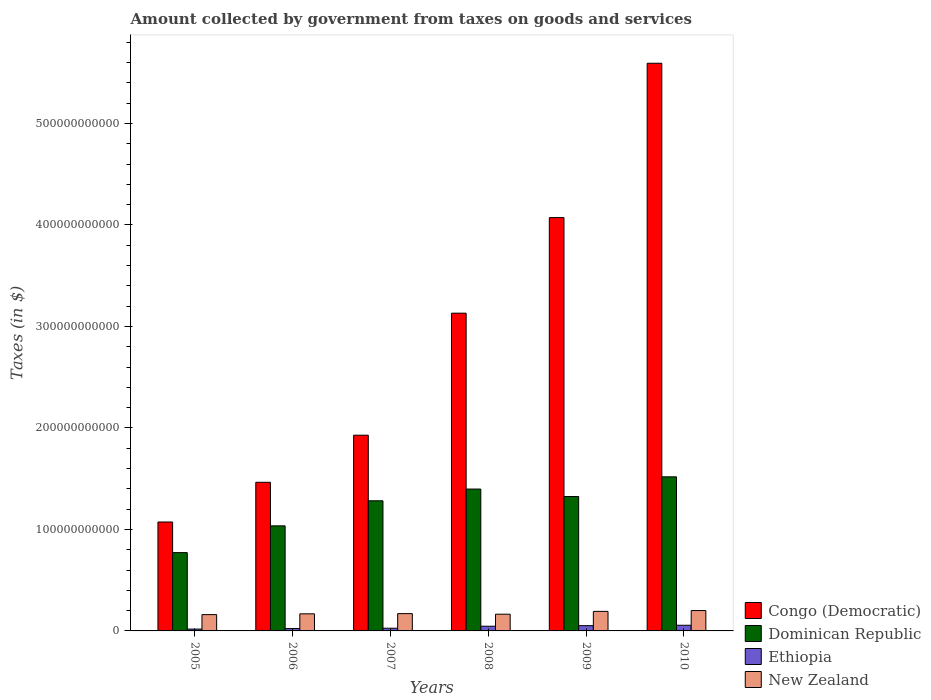How many different coloured bars are there?
Your response must be concise. 4. Are the number of bars on each tick of the X-axis equal?
Provide a succinct answer. Yes. In how many cases, is the number of bars for a given year not equal to the number of legend labels?
Provide a succinct answer. 0. What is the amount collected by government from taxes on goods and services in Dominican Republic in 2006?
Keep it short and to the point. 1.04e+11. Across all years, what is the maximum amount collected by government from taxes on goods and services in Dominican Republic?
Provide a short and direct response. 1.52e+11. Across all years, what is the minimum amount collected by government from taxes on goods and services in Dominican Republic?
Offer a terse response. 7.71e+1. In which year was the amount collected by government from taxes on goods and services in Congo (Democratic) maximum?
Provide a succinct answer. 2010. What is the total amount collected by government from taxes on goods and services in Congo (Democratic) in the graph?
Provide a short and direct response. 1.73e+12. What is the difference between the amount collected by government from taxes on goods and services in Ethiopia in 2006 and that in 2008?
Provide a short and direct response. -2.31e+09. What is the difference between the amount collected by government from taxes on goods and services in New Zealand in 2010 and the amount collected by government from taxes on goods and services in Ethiopia in 2006?
Make the answer very short. 1.77e+1. What is the average amount collected by government from taxes on goods and services in Congo (Democratic) per year?
Give a very brief answer. 2.88e+11. In the year 2006, what is the difference between the amount collected by government from taxes on goods and services in Ethiopia and amount collected by government from taxes on goods and services in New Zealand?
Your answer should be very brief. -1.45e+1. What is the ratio of the amount collected by government from taxes on goods and services in Congo (Democratic) in 2007 to that in 2008?
Offer a terse response. 0.62. What is the difference between the highest and the second highest amount collected by government from taxes on goods and services in New Zealand?
Offer a terse response. 8.25e+08. What is the difference between the highest and the lowest amount collected by government from taxes on goods and services in New Zealand?
Provide a succinct answer. 4.00e+09. In how many years, is the amount collected by government from taxes on goods and services in Dominican Republic greater than the average amount collected by government from taxes on goods and services in Dominican Republic taken over all years?
Ensure brevity in your answer.  4. Is the sum of the amount collected by government from taxes on goods and services in Dominican Republic in 2005 and 2008 greater than the maximum amount collected by government from taxes on goods and services in New Zealand across all years?
Your answer should be compact. Yes. What does the 4th bar from the left in 2009 represents?
Keep it short and to the point. New Zealand. What does the 4th bar from the right in 2006 represents?
Your answer should be very brief. Congo (Democratic). How many bars are there?
Keep it short and to the point. 24. Are all the bars in the graph horizontal?
Make the answer very short. No. What is the difference between two consecutive major ticks on the Y-axis?
Your answer should be very brief. 1.00e+11. How are the legend labels stacked?
Your answer should be very brief. Vertical. What is the title of the graph?
Your response must be concise. Amount collected by government from taxes on goods and services. What is the label or title of the X-axis?
Make the answer very short. Years. What is the label or title of the Y-axis?
Ensure brevity in your answer.  Taxes (in $). What is the Taxes (in $) in Congo (Democratic) in 2005?
Provide a short and direct response. 1.07e+11. What is the Taxes (in $) of Dominican Republic in 2005?
Your answer should be compact. 7.71e+1. What is the Taxes (in $) in Ethiopia in 2005?
Make the answer very short. 1.82e+09. What is the Taxes (in $) of New Zealand in 2005?
Offer a very short reply. 1.61e+1. What is the Taxes (in $) in Congo (Democratic) in 2006?
Provide a short and direct response. 1.46e+11. What is the Taxes (in $) of Dominican Republic in 2006?
Give a very brief answer. 1.04e+11. What is the Taxes (in $) in Ethiopia in 2006?
Your answer should be compact. 2.33e+09. What is the Taxes (in $) of New Zealand in 2006?
Your answer should be compact. 1.68e+1. What is the Taxes (in $) in Congo (Democratic) in 2007?
Offer a terse response. 1.93e+11. What is the Taxes (in $) of Dominican Republic in 2007?
Give a very brief answer. 1.28e+11. What is the Taxes (in $) in Ethiopia in 2007?
Provide a succinct answer. 2.66e+09. What is the Taxes (in $) of New Zealand in 2007?
Give a very brief answer. 1.70e+1. What is the Taxes (in $) in Congo (Democratic) in 2008?
Offer a very short reply. 3.13e+11. What is the Taxes (in $) of Dominican Republic in 2008?
Ensure brevity in your answer.  1.40e+11. What is the Taxes (in $) in Ethiopia in 2008?
Your answer should be compact. 4.63e+09. What is the Taxes (in $) of New Zealand in 2008?
Your response must be concise. 1.65e+1. What is the Taxes (in $) of Congo (Democratic) in 2009?
Provide a short and direct response. 4.07e+11. What is the Taxes (in $) in Dominican Republic in 2009?
Your answer should be very brief. 1.32e+11. What is the Taxes (in $) in Ethiopia in 2009?
Provide a short and direct response. 5.20e+09. What is the Taxes (in $) of New Zealand in 2009?
Offer a terse response. 1.92e+1. What is the Taxes (in $) of Congo (Democratic) in 2010?
Offer a terse response. 5.59e+11. What is the Taxes (in $) in Dominican Republic in 2010?
Offer a very short reply. 1.52e+11. What is the Taxes (in $) of Ethiopia in 2010?
Your response must be concise. 5.58e+09. What is the Taxes (in $) of New Zealand in 2010?
Offer a very short reply. 2.01e+1. Across all years, what is the maximum Taxes (in $) in Congo (Democratic)?
Keep it short and to the point. 5.59e+11. Across all years, what is the maximum Taxes (in $) in Dominican Republic?
Your answer should be very brief. 1.52e+11. Across all years, what is the maximum Taxes (in $) of Ethiopia?
Offer a very short reply. 5.58e+09. Across all years, what is the maximum Taxes (in $) of New Zealand?
Your answer should be compact. 2.01e+1. Across all years, what is the minimum Taxes (in $) of Congo (Democratic)?
Your response must be concise. 1.07e+11. Across all years, what is the minimum Taxes (in $) in Dominican Republic?
Keep it short and to the point. 7.71e+1. Across all years, what is the minimum Taxes (in $) in Ethiopia?
Keep it short and to the point. 1.82e+09. Across all years, what is the minimum Taxes (in $) of New Zealand?
Give a very brief answer. 1.61e+1. What is the total Taxes (in $) of Congo (Democratic) in the graph?
Give a very brief answer. 1.73e+12. What is the total Taxes (in $) of Dominican Republic in the graph?
Give a very brief answer. 7.33e+11. What is the total Taxes (in $) in Ethiopia in the graph?
Your answer should be very brief. 2.22e+1. What is the total Taxes (in $) of New Zealand in the graph?
Give a very brief answer. 1.06e+11. What is the difference between the Taxes (in $) in Congo (Democratic) in 2005 and that in 2006?
Give a very brief answer. -3.91e+1. What is the difference between the Taxes (in $) of Dominican Republic in 2005 and that in 2006?
Offer a very short reply. -2.64e+1. What is the difference between the Taxes (in $) in Ethiopia in 2005 and that in 2006?
Provide a succinct answer. -5.09e+08. What is the difference between the Taxes (in $) of New Zealand in 2005 and that in 2006?
Your answer should be compact. -7.69e+08. What is the difference between the Taxes (in $) in Congo (Democratic) in 2005 and that in 2007?
Provide a succinct answer. -8.55e+1. What is the difference between the Taxes (in $) of Dominican Republic in 2005 and that in 2007?
Make the answer very short. -5.11e+1. What is the difference between the Taxes (in $) in Ethiopia in 2005 and that in 2007?
Provide a short and direct response. -8.40e+08. What is the difference between the Taxes (in $) in New Zealand in 2005 and that in 2007?
Offer a terse response. -9.82e+08. What is the difference between the Taxes (in $) in Congo (Democratic) in 2005 and that in 2008?
Provide a short and direct response. -2.06e+11. What is the difference between the Taxes (in $) of Dominican Republic in 2005 and that in 2008?
Provide a short and direct response. -6.26e+1. What is the difference between the Taxes (in $) of Ethiopia in 2005 and that in 2008?
Keep it short and to the point. -2.81e+09. What is the difference between the Taxes (in $) in New Zealand in 2005 and that in 2008?
Offer a terse response. -4.10e+08. What is the difference between the Taxes (in $) of Congo (Democratic) in 2005 and that in 2009?
Your answer should be compact. -3.00e+11. What is the difference between the Taxes (in $) in Dominican Republic in 2005 and that in 2009?
Keep it short and to the point. -5.53e+1. What is the difference between the Taxes (in $) in Ethiopia in 2005 and that in 2009?
Your response must be concise. -3.38e+09. What is the difference between the Taxes (in $) of New Zealand in 2005 and that in 2009?
Give a very brief answer. -3.18e+09. What is the difference between the Taxes (in $) in Congo (Democratic) in 2005 and that in 2010?
Your answer should be very brief. -4.52e+11. What is the difference between the Taxes (in $) of Dominican Republic in 2005 and that in 2010?
Make the answer very short. -7.47e+1. What is the difference between the Taxes (in $) in Ethiopia in 2005 and that in 2010?
Provide a succinct answer. -3.77e+09. What is the difference between the Taxes (in $) in New Zealand in 2005 and that in 2010?
Provide a short and direct response. -4.00e+09. What is the difference between the Taxes (in $) in Congo (Democratic) in 2006 and that in 2007?
Your answer should be very brief. -4.64e+1. What is the difference between the Taxes (in $) in Dominican Republic in 2006 and that in 2007?
Your answer should be very brief. -2.47e+1. What is the difference between the Taxes (in $) in Ethiopia in 2006 and that in 2007?
Ensure brevity in your answer.  -3.31e+08. What is the difference between the Taxes (in $) in New Zealand in 2006 and that in 2007?
Your response must be concise. -2.13e+08. What is the difference between the Taxes (in $) in Congo (Democratic) in 2006 and that in 2008?
Keep it short and to the point. -1.67e+11. What is the difference between the Taxes (in $) in Dominican Republic in 2006 and that in 2008?
Provide a short and direct response. -3.62e+1. What is the difference between the Taxes (in $) of Ethiopia in 2006 and that in 2008?
Your answer should be compact. -2.31e+09. What is the difference between the Taxes (in $) of New Zealand in 2006 and that in 2008?
Give a very brief answer. 3.59e+08. What is the difference between the Taxes (in $) of Congo (Democratic) in 2006 and that in 2009?
Give a very brief answer. -2.61e+11. What is the difference between the Taxes (in $) of Dominican Republic in 2006 and that in 2009?
Keep it short and to the point. -2.89e+1. What is the difference between the Taxes (in $) of Ethiopia in 2006 and that in 2009?
Your answer should be compact. -2.87e+09. What is the difference between the Taxes (in $) in New Zealand in 2006 and that in 2009?
Provide a short and direct response. -2.41e+09. What is the difference between the Taxes (in $) in Congo (Democratic) in 2006 and that in 2010?
Offer a terse response. -4.13e+11. What is the difference between the Taxes (in $) in Dominican Republic in 2006 and that in 2010?
Your response must be concise. -4.83e+1. What is the difference between the Taxes (in $) of Ethiopia in 2006 and that in 2010?
Offer a terse response. -3.26e+09. What is the difference between the Taxes (in $) of New Zealand in 2006 and that in 2010?
Your answer should be compact. -3.24e+09. What is the difference between the Taxes (in $) of Congo (Democratic) in 2007 and that in 2008?
Keep it short and to the point. -1.20e+11. What is the difference between the Taxes (in $) of Dominican Republic in 2007 and that in 2008?
Offer a very short reply. -1.16e+1. What is the difference between the Taxes (in $) of Ethiopia in 2007 and that in 2008?
Provide a succinct answer. -1.97e+09. What is the difference between the Taxes (in $) of New Zealand in 2007 and that in 2008?
Your answer should be very brief. 5.72e+08. What is the difference between the Taxes (in $) of Congo (Democratic) in 2007 and that in 2009?
Make the answer very short. -2.14e+11. What is the difference between the Taxes (in $) in Dominican Republic in 2007 and that in 2009?
Make the answer very short. -4.20e+09. What is the difference between the Taxes (in $) in Ethiopia in 2007 and that in 2009?
Provide a succinct answer. -2.54e+09. What is the difference between the Taxes (in $) in New Zealand in 2007 and that in 2009?
Your answer should be very brief. -2.20e+09. What is the difference between the Taxes (in $) of Congo (Democratic) in 2007 and that in 2010?
Ensure brevity in your answer.  -3.66e+11. What is the difference between the Taxes (in $) of Dominican Republic in 2007 and that in 2010?
Offer a terse response. -2.36e+1. What is the difference between the Taxes (in $) of Ethiopia in 2007 and that in 2010?
Keep it short and to the point. -2.93e+09. What is the difference between the Taxes (in $) of New Zealand in 2007 and that in 2010?
Make the answer very short. -3.02e+09. What is the difference between the Taxes (in $) in Congo (Democratic) in 2008 and that in 2009?
Give a very brief answer. -9.42e+1. What is the difference between the Taxes (in $) in Dominican Republic in 2008 and that in 2009?
Offer a very short reply. 7.36e+09. What is the difference between the Taxes (in $) in Ethiopia in 2008 and that in 2009?
Keep it short and to the point. -5.68e+08. What is the difference between the Taxes (in $) in New Zealand in 2008 and that in 2009?
Keep it short and to the point. -2.77e+09. What is the difference between the Taxes (in $) in Congo (Democratic) in 2008 and that in 2010?
Your answer should be compact. -2.46e+11. What is the difference between the Taxes (in $) of Dominican Republic in 2008 and that in 2010?
Ensure brevity in your answer.  -1.20e+1. What is the difference between the Taxes (in $) of Ethiopia in 2008 and that in 2010?
Your answer should be compact. -9.51e+08. What is the difference between the Taxes (in $) of New Zealand in 2008 and that in 2010?
Give a very brief answer. -3.60e+09. What is the difference between the Taxes (in $) in Congo (Democratic) in 2009 and that in 2010?
Provide a succinct answer. -1.52e+11. What is the difference between the Taxes (in $) in Dominican Republic in 2009 and that in 2010?
Provide a short and direct response. -1.94e+1. What is the difference between the Taxes (in $) in Ethiopia in 2009 and that in 2010?
Offer a very short reply. -3.83e+08. What is the difference between the Taxes (in $) in New Zealand in 2009 and that in 2010?
Provide a succinct answer. -8.25e+08. What is the difference between the Taxes (in $) in Congo (Democratic) in 2005 and the Taxes (in $) in Dominican Republic in 2006?
Offer a terse response. 3.81e+09. What is the difference between the Taxes (in $) in Congo (Democratic) in 2005 and the Taxes (in $) in Ethiopia in 2006?
Give a very brief answer. 1.05e+11. What is the difference between the Taxes (in $) of Congo (Democratic) in 2005 and the Taxes (in $) of New Zealand in 2006?
Offer a very short reply. 9.05e+1. What is the difference between the Taxes (in $) of Dominican Republic in 2005 and the Taxes (in $) of Ethiopia in 2006?
Your answer should be compact. 7.48e+1. What is the difference between the Taxes (in $) of Dominican Republic in 2005 and the Taxes (in $) of New Zealand in 2006?
Offer a very short reply. 6.03e+1. What is the difference between the Taxes (in $) in Ethiopia in 2005 and the Taxes (in $) in New Zealand in 2006?
Your response must be concise. -1.50e+1. What is the difference between the Taxes (in $) in Congo (Democratic) in 2005 and the Taxes (in $) in Dominican Republic in 2007?
Provide a succinct answer. -2.09e+1. What is the difference between the Taxes (in $) in Congo (Democratic) in 2005 and the Taxes (in $) in Ethiopia in 2007?
Ensure brevity in your answer.  1.05e+11. What is the difference between the Taxes (in $) of Congo (Democratic) in 2005 and the Taxes (in $) of New Zealand in 2007?
Ensure brevity in your answer.  9.03e+1. What is the difference between the Taxes (in $) of Dominican Republic in 2005 and the Taxes (in $) of Ethiopia in 2007?
Provide a succinct answer. 7.45e+1. What is the difference between the Taxes (in $) of Dominican Republic in 2005 and the Taxes (in $) of New Zealand in 2007?
Offer a terse response. 6.01e+1. What is the difference between the Taxes (in $) in Ethiopia in 2005 and the Taxes (in $) in New Zealand in 2007?
Make the answer very short. -1.52e+1. What is the difference between the Taxes (in $) in Congo (Democratic) in 2005 and the Taxes (in $) in Dominican Republic in 2008?
Your answer should be compact. -3.24e+1. What is the difference between the Taxes (in $) in Congo (Democratic) in 2005 and the Taxes (in $) in Ethiopia in 2008?
Your answer should be very brief. 1.03e+11. What is the difference between the Taxes (in $) in Congo (Democratic) in 2005 and the Taxes (in $) in New Zealand in 2008?
Provide a short and direct response. 9.08e+1. What is the difference between the Taxes (in $) in Dominican Republic in 2005 and the Taxes (in $) in Ethiopia in 2008?
Give a very brief answer. 7.25e+1. What is the difference between the Taxes (in $) in Dominican Republic in 2005 and the Taxes (in $) in New Zealand in 2008?
Make the answer very short. 6.07e+1. What is the difference between the Taxes (in $) in Ethiopia in 2005 and the Taxes (in $) in New Zealand in 2008?
Provide a short and direct response. -1.47e+1. What is the difference between the Taxes (in $) of Congo (Democratic) in 2005 and the Taxes (in $) of Dominican Republic in 2009?
Provide a succinct answer. -2.51e+1. What is the difference between the Taxes (in $) of Congo (Democratic) in 2005 and the Taxes (in $) of Ethiopia in 2009?
Give a very brief answer. 1.02e+11. What is the difference between the Taxes (in $) of Congo (Democratic) in 2005 and the Taxes (in $) of New Zealand in 2009?
Your answer should be very brief. 8.81e+1. What is the difference between the Taxes (in $) in Dominican Republic in 2005 and the Taxes (in $) in Ethiopia in 2009?
Ensure brevity in your answer.  7.19e+1. What is the difference between the Taxes (in $) of Dominican Republic in 2005 and the Taxes (in $) of New Zealand in 2009?
Keep it short and to the point. 5.79e+1. What is the difference between the Taxes (in $) in Ethiopia in 2005 and the Taxes (in $) in New Zealand in 2009?
Your response must be concise. -1.74e+1. What is the difference between the Taxes (in $) in Congo (Democratic) in 2005 and the Taxes (in $) in Dominican Republic in 2010?
Your answer should be very brief. -4.45e+1. What is the difference between the Taxes (in $) in Congo (Democratic) in 2005 and the Taxes (in $) in Ethiopia in 2010?
Provide a short and direct response. 1.02e+11. What is the difference between the Taxes (in $) of Congo (Democratic) in 2005 and the Taxes (in $) of New Zealand in 2010?
Provide a succinct answer. 8.73e+1. What is the difference between the Taxes (in $) of Dominican Republic in 2005 and the Taxes (in $) of Ethiopia in 2010?
Keep it short and to the point. 7.16e+1. What is the difference between the Taxes (in $) in Dominican Republic in 2005 and the Taxes (in $) in New Zealand in 2010?
Offer a terse response. 5.71e+1. What is the difference between the Taxes (in $) of Ethiopia in 2005 and the Taxes (in $) of New Zealand in 2010?
Offer a very short reply. -1.83e+1. What is the difference between the Taxes (in $) of Congo (Democratic) in 2006 and the Taxes (in $) of Dominican Republic in 2007?
Give a very brief answer. 1.82e+1. What is the difference between the Taxes (in $) of Congo (Democratic) in 2006 and the Taxes (in $) of Ethiopia in 2007?
Give a very brief answer. 1.44e+11. What is the difference between the Taxes (in $) of Congo (Democratic) in 2006 and the Taxes (in $) of New Zealand in 2007?
Offer a terse response. 1.29e+11. What is the difference between the Taxes (in $) in Dominican Republic in 2006 and the Taxes (in $) in Ethiopia in 2007?
Keep it short and to the point. 1.01e+11. What is the difference between the Taxes (in $) in Dominican Republic in 2006 and the Taxes (in $) in New Zealand in 2007?
Offer a terse response. 8.65e+1. What is the difference between the Taxes (in $) in Ethiopia in 2006 and the Taxes (in $) in New Zealand in 2007?
Your answer should be very brief. -1.47e+1. What is the difference between the Taxes (in $) of Congo (Democratic) in 2006 and the Taxes (in $) of Dominican Republic in 2008?
Keep it short and to the point. 6.66e+09. What is the difference between the Taxes (in $) in Congo (Democratic) in 2006 and the Taxes (in $) in Ethiopia in 2008?
Your answer should be very brief. 1.42e+11. What is the difference between the Taxes (in $) in Congo (Democratic) in 2006 and the Taxes (in $) in New Zealand in 2008?
Provide a short and direct response. 1.30e+11. What is the difference between the Taxes (in $) of Dominican Republic in 2006 and the Taxes (in $) of Ethiopia in 2008?
Your answer should be very brief. 9.89e+1. What is the difference between the Taxes (in $) in Dominican Republic in 2006 and the Taxes (in $) in New Zealand in 2008?
Your response must be concise. 8.70e+1. What is the difference between the Taxes (in $) of Ethiopia in 2006 and the Taxes (in $) of New Zealand in 2008?
Provide a succinct answer. -1.41e+1. What is the difference between the Taxes (in $) of Congo (Democratic) in 2006 and the Taxes (in $) of Dominican Republic in 2009?
Give a very brief answer. 1.40e+1. What is the difference between the Taxes (in $) of Congo (Democratic) in 2006 and the Taxes (in $) of Ethiopia in 2009?
Your response must be concise. 1.41e+11. What is the difference between the Taxes (in $) in Congo (Democratic) in 2006 and the Taxes (in $) in New Zealand in 2009?
Give a very brief answer. 1.27e+11. What is the difference between the Taxes (in $) in Dominican Republic in 2006 and the Taxes (in $) in Ethiopia in 2009?
Your answer should be compact. 9.83e+1. What is the difference between the Taxes (in $) in Dominican Republic in 2006 and the Taxes (in $) in New Zealand in 2009?
Offer a terse response. 8.43e+1. What is the difference between the Taxes (in $) in Ethiopia in 2006 and the Taxes (in $) in New Zealand in 2009?
Your answer should be compact. -1.69e+1. What is the difference between the Taxes (in $) in Congo (Democratic) in 2006 and the Taxes (in $) in Dominican Republic in 2010?
Provide a succinct answer. -5.37e+09. What is the difference between the Taxes (in $) of Congo (Democratic) in 2006 and the Taxes (in $) of Ethiopia in 2010?
Provide a succinct answer. 1.41e+11. What is the difference between the Taxes (in $) of Congo (Democratic) in 2006 and the Taxes (in $) of New Zealand in 2010?
Your answer should be very brief. 1.26e+11. What is the difference between the Taxes (in $) of Dominican Republic in 2006 and the Taxes (in $) of Ethiopia in 2010?
Provide a short and direct response. 9.79e+1. What is the difference between the Taxes (in $) of Dominican Republic in 2006 and the Taxes (in $) of New Zealand in 2010?
Give a very brief answer. 8.34e+1. What is the difference between the Taxes (in $) in Ethiopia in 2006 and the Taxes (in $) in New Zealand in 2010?
Ensure brevity in your answer.  -1.77e+1. What is the difference between the Taxes (in $) of Congo (Democratic) in 2007 and the Taxes (in $) of Dominican Republic in 2008?
Offer a very short reply. 5.31e+1. What is the difference between the Taxes (in $) of Congo (Democratic) in 2007 and the Taxes (in $) of Ethiopia in 2008?
Give a very brief answer. 1.88e+11. What is the difference between the Taxes (in $) in Congo (Democratic) in 2007 and the Taxes (in $) in New Zealand in 2008?
Provide a succinct answer. 1.76e+11. What is the difference between the Taxes (in $) of Dominican Republic in 2007 and the Taxes (in $) of Ethiopia in 2008?
Ensure brevity in your answer.  1.24e+11. What is the difference between the Taxes (in $) of Dominican Republic in 2007 and the Taxes (in $) of New Zealand in 2008?
Offer a very short reply. 1.12e+11. What is the difference between the Taxes (in $) in Ethiopia in 2007 and the Taxes (in $) in New Zealand in 2008?
Offer a terse response. -1.38e+1. What is the difference between the Taxes (in $) in Congo (Democratic) in 2007 and the Taxes (in $) in Dominican Republic in 2009?
Provide a succinct answer. 6.04e+1. What is the difference between the Taxes (in $) of Congo (Democratic) in 2007 and the Taxes (in $) of Ethiopia in 2009?
Make the answer very short. 1.88e+11. What is the difference between the Taxes (in $) in Congo (Democratic) in 2007 and the Taxes (in $) in New Zealand in 2009?
Give a very brief answer. 1.74e+11. What is the difference between the Taxes (in $) in Dominican Republic in 2007 and the Taxes (in $) in Ethiopia in 2009?
Ensure brevity in your answer.  1.23e+11. What is the difference between the Taxes (in $) of Dominican Republic in 2007 and the Taxes (in $) of New Zealand in 2009?
Ensure brevity in your answer.  1.09e+11. What is the difference between the Taxes (in $) in Ethiopia in 2007 and the Taxes (in $) in New Zealand in 2009?
Provide a succinct answer. -1.66e+1. What is the difference between the Taxes (in $) of Congo (Democratic) in 2007 and the Taxes (in $) of Dominican Republic in 2010?
Your answer should be compact. 4.10e+1. What is the difference between the Taxes (in $) of Congo (Democratic) in 2007 and the Taxes (in $) of Ethiopia in 2010?
Provide a succinct answer. 1.87e+11. What is the difference between the Taxes (in $) of Congo (Democratic) in 2007 and the Taxes (in $) of New Zealand in 2010?
Keep it short and to the point. 1.73e+11. What is the difference between the Taxes (in $) of Dominican Republic in 2007 and the Taxes (in $) of Ethiopia in 2010?
Ensure brevity in your answer.  1.23e+11. What is the difference between the Taxes (in $) of Dominican Republic in 2007 and the Taxes (in $) of New Zealand in 2010?
Offer a terse response. 1.08e+11. What is the difference between the Taxes (in $) in Ethiopia in 2007 and the Taxes (in $) in New Zealand in 2010?
Provide a short and direct response. -1.74e+1. What is the difference between the Taxes (in $) of Congo (Democratic) in 2008 and the Taxes (in $) of Dominican Republic in 2009?
Your response must be concise. 1.81e+11. What is the difference between the Taxes (in $) in Congo (Democratic) in 2008 and the Taxes (in $) in Ethiopia in 2009?
Offer a very short reply. 3.08e+11. What is the difference between the Taxes (in $) of Congo (Democratic) in 2008 and the Taxes (in $) of New Zealand in 2009?
Provide a short and direct response. 2.94e+11. What is the difference between the Taxes (in $) in Dominican Republic in 2008 and the Taxes (in $) in Ethiopia in 2009?
Offer a terse response. 1.35e+11. What is the difference between the Taxes (in $) in Dominican Republic in 2008 and the Taxes (in $) in New Zealand in 2009?
Your response must be concise. 1.21e+11. What is the difference between the Taxes (in $) of Ethiopia in 2008 and the Taxes (in $) of New Zealand in 2009?
Your answer should be very brief. -1.46e+1. What is the difference between the Taxes (in $) of Congo (Democratic) in 2008 and the Taxes (in $) of Dominican Republic in 2010?
Keep it short and to the point. 1.61e+11. What is the difference between the Taxes (in $) in Congo (Democratic) in 2008 and the Taxes (in $) in Ethiopia in 2010?
Offer a terse response. 3.07e+11. What is the difference between the Taxes (in $) of Congo (Democratic) in 2008 and the Taxes (in $) of New Zealand in 2010?
Your response must be concise. 2.93e+11. What is the difference between the Taxes (in $) of Dominican Republic in 2008 and the Taxes (in $) of Ethiopia in 2010?
Provide a short and direct response. 1.34e+11. What is the difference between the Taxes (in $) in Dominican Republic in 2008 and the Taxes (in $) in New Zealand in 2010?
Provide a succinct answer. 1.20e+11. What is the difference between the Taxes (in $) in Ethiopia in 2008 and the Taxes (in $) in New Zealand in 2010?
Your answer should be very brief. -1.54e+1. What is the difference between the Taxes (in $) in Congo (Democratic) in 2009 and the Taxes (in $) in Dominican Republic in 2010?
Offer a terse response. 2.55e+11. What is the difference between the Taxes (in $) in Congo (Democratic) in 2009 and the Taxes (in $) in Ethiopia in 2010?
Keep it short and to the point. 4.02e+11. What is the difference between the Taxes (in $) in Congo (Democratic) in 2009 and the Taxes (in $) in New Zealand in 2010?
Your answer should be compact. 3.87e+11. What is the difference between the Taxes (in $) in Dominican Republic in 2009 and the Taxes (in $) in Ethiopia in 2010?
Your answer should be very brief. 1.27e+11. What is the difference between the Taxes (in $) in Dominican Republic in 2009 and the Taxes (in $) in New Zealand in 2010?
Ensure brevity in your answer.  1.12e+11. What is the difference between the Taxes (in $) of Ethiopia in 2009 and the Taxes (in $) of New Zealand in 2010?
Your answer should be very brief. -1.49e+1. What is the average Taxes (in $) of Congo (Democratic) per year?
Provide a succinct answer. 2.88e+11. What is the average Taxes (in $) of Dominican Republic per year?
Keep it short and to the point. 1.22e+11. What is the average Taxes (in $) in Ethiopia per year?
Your answer should be compact. 3.70e+09. What is the average Taxes (in $) of New Zealand per year?
Provide a short and direct response. 1.76e+1. In the year 2005, what is the difference between the Taxes (in $) of Congo (Democratic) and Taxes (in $) of Dominican Republic?
Ensure brevity in your answer.  3.02e+1. In the year 2005, what is the difference between the Taxes (in $) in Congo (Democratic) and Taxes (in $) in Ethiopia?
Your answer should be very brief. 1.06e+11. In the year 2005, what is the difference between the Taxes (in $) of Congo (Democratic) and Taxes (in $) of New Zealand?
Provide a short and direct response. 9.13e+1. In the year 2005, what is the difference between the Taxes (in $) in Dominican Republic and Taxes (in $) in Ethiopia?
Provide a succinct answer. 7.53e+1. In the year 2005, what is the difference between the Taxes (in $) in Dominican Republic and Taxes (in $) in New Zealand?
Offer a terse response. 6.11e+1. In the year 2005, what is the difference between the Taxes (in $) in Ethiopia and Taxes (in $) in New Zealand?
Ensure brevity in your answer.  -1.42e+1. In the year 2006, what is the difference between the Taxes (in $) of Congo (Democratic) and Taxes (in $) of Dominican Republic?
Make the answer very short. 4.29e+1. In the year 2006, what is the difference between the Taxes (in $) of Congo (Democratic) and Taxes (in $) of Ethiopia?
Your answer should be compact. 1.44e+11. In the year 2006, what is the difference between the Taxes (in $) of Congo (Democratic) and Taxes (in $) of New Zealand?
Make the answer very short. 1.30e+11. In the year 2006, what is the difference between the Taxes (in $) in Dominican Republic and Taxes (in $) in Ethiopia?
Offer a very short reply. 1.01e+11. In the year 2006, what is the difference between the Taxes (in $) of Dominican Republic and Taxes (in $) of New Zealand?
Provide a short and direct response. 8.67e+1. In the year 2006, what is the difference between the Taxes (in $) in Ethiopia and Taxes (in $) in New Zealand?
Make the answer very short. -1.45e+1. In the year 2007, what is the difference between the Taxes (in $) in Congo (Democratic) and Taxes (in $) in Dominican Republic?
Your response must be concise. 6.46e+1. In the year 2007, what is the difference between the Taxes (in $) in Congo (Democratic) and Taxes (in $) in Ethiopia?
Your response must be concise. 1.90e+11. In the year 2007, what is the difference between the Taxes (in $) in Congo (Democratic) and Taxes (in $) in New Zealand?
Provide a succinct answer. 1.76e+11. In the year 2007, what is the difference between the Taxes (in $) of Dominican Republic and Taxes (in $) of Ethiopia?
Offer a very short reply. 1.26e+11. In the year 2007, what is the difference between the Taxes (in $) in Dominican Republic and Taxes (in $) in New Zealand?
Keep it short and to the point. 1.11e+11. In the year 2007, what is the difference between the Taxes (in $) of Ethiopia and Taxes (in $) of New Zealand?
Offer a very short reply. -1.44e+1. In the year 2008, what is the difference between the Taxes (in $) in Congo (Democratic) and Taxes (in $) in Dominican Republic?
Offer a very short reply. 1.73e+11. In the year 2008, what is the difference between the Taxes (in $) of Congo (Democratic) and Taxes (in $) of Ethiopia?
Offer a very short reply. 3.08e+11. In the year 2008, what is the difference between the Taxes (in $) of Congo (Democratic) and Taxes (in $) of New Zealand?
Provide a succinct answer. 2.97e+11. In the year 2008, what is the difference between the Taxes (in $) in Dominican Republic and Taxes (in $) in Ethiopia?
Offer a very short reply. 1.35e+11. In the year 2008, what is the difference between the Taxes (in $) in Dominican Republic and Taxes (in $) in New Zealand?
Your answer should be compact. 1.23e+11. In the year 2008, what is the difference between the Taxes (in $) of Ethiopia and Taxes (in $) of New Zealand?
Provide a short and direct response. -1.18e+1. In the year 2009, what is the difference between the Taxes (in $) in Congo (Democratic) and Taxes (in $) in Dominican Republic?
Provide a short and direct response. 2.75e+11. In the year 2009, what is the difference between the Taxes (in $) of Congo (Democratic) and Taxes (in $) of Ethiopia?
Your response must be concise. 4.02e+11. In the year 2009, what is the difference between the Taxes (in $) of Congo (Democratic) and Taxes (in $) of New Zealand?
Your answer should be very brief. 3.88e+11. In the year 2009, what is the difference between the Taxes (in $) in Dominican Republic and Taxes (in $) in Ethiopia?
Ensure brevity in your answer.  1.27e+11. In the year 2009, what is the difference between the Taxes (in $) in Dominican Republic and Taxes (in $) in New Zealand?
Make the answer very short. 1.13e+11. In the year 2009, what is the difference between the Taxes (in $) of Ethiopia and Taxes (in $) of New Zealand?
Give a very brief answer. -1.40e+1. In the year 2010, what is the difference between the Taxes (in $) in Congo (Democratic) and Taxes (in $) in Dominican Republic?
Ensure brevity in your answer.  4.07e+11. In the year 2010, what is the difference between the Taxes (in $) of Congo (Democratic) and Taxes (in $) of Ethiopia?
Your response must be concise. 5.54e+11. In the year 2010, what is the difference between the Taxes (in $) in Congo (Democratic) and Taxes (in $) in New Zealand?
Offer a very short reply. 5.39e+11. In the year 2010, what is the difference between the Taxes (in $) of Dominican Republic and Taxes (in $) of Ethiopia?
Keep it short and to the point. 1.46e+11. In the year 2010, what is the difference between the Taxes (in $) of Dominican Republic and Taxes (in $) of New Zealand?
Keep it short and to the point. 1.32e+11. In the year 2010, what is the difference between the Taxes (in $) in Ethiopia and Taxes (in $) in New Zealand?
Keep it short and to the point. -1.45e+1. What is the ratio of the Taxes (in $) of Congo (Democratic) in 2005 to that in 2006?
Keep it short and to the point. 0.73. What is the ratio of the Taxes (in $) of Dominican Republic in 2005 to that in 2006?
Provide a short and direct response. 0.75. What is the ratio of the Taxes (in $) in Ethiopia in 2005 to that in 2006?
Provide a short and direct response. 0.78. What is the ratio of the Taxes (in $) of New Zealand in 2005 to that in 2006?
Your response must be concise. 0.95. What is the ratio of the Taxes (in $) of Congo (Democratic) in 2005 to that in 2007?
Keep it short and to the point. 0.56. What is the ratio of the Taxes (in $) in Dominican Republic in 2005 to that in 2007?
Your answer should be very brief. 0.6. What is the ratio of the Taxes (in $) in Ethiopia in 2005 to that in 2007?
Keep it short and to the point. 0.68. What is the ratio of the Taxes (in $) in New Zealand in 2005 to that in 2007?
Your answer should be very brief. 0.94. What is the ratio of the Taxes (in $) in Congo (Democratic) in 2005 to that in 2008?
Your answer should be compact. 0.34. What is the ratio of the Taxes (in $) in Dominican Republic in 2005 to that in 2008?
Provide a short and direct response. 0.55. What is the ratio of the Taxes (in $) in Ethiopia in 2005 to that in 2008?
Keep it short and to the point. 0.39. What is the ratio of the Taxes (in $) in New Zealand in 2005 to that in 2008?
Make the answer very short. 0.98. What is the ratio of the Taxes (in $) of Congo (Democratic) in 2005 to that in 2009?
Give a very brief answer. 0.26. What is the ratio of the Taxes (in $) in Dominican Republic in 2005 to that in 2009?
Make the answer very short. 0.58. What is the ratio of the Taxes (in $) of Ethiopia in 2005 to that in 2009?
Give a very brief answer. 0.35. What is the ratio of the Taxes (in $) of New Zealand in 2005 to that in 2009?
Your answer should be very brief. 0.83. What is the ratio of the Taxes (in $) of Congo (Democratic) in 2005 to that in 2010?
Your answer should be very brief. 0.19. What is the ratio of the Taxes (in $) of Dominican Republic in 2005 to that in 2010?
Your answer should be compact. 0.51. What is the ratio of the Taxes (in $) of Ethiopia in 2005 to that in 2010?
Offer a terse response. 0.33. What is the ratio of the Taxes (in $) in New Zealand in 2005 to that in 2010?
Give a very brief answer. 0.8. What is the ratio of the Taxes (in $) of Congo (Democratic) in 2006 to that in 2007?
Offer a terse response. 0.76. What is the ratio of the Taxes (in $) in Dominican Republic in 2006 to that in 2007?
Give a very brief answer. 0.81. What is the ratio of the Taxes (in $) of Ethiopia in 2006 to that in 2007?
Offer a very short reply. 0.88. What is the ratio of the Taxes (in $) of New Zealand in 2006 to that in 2007?
Make the answer very short. 0.99. What is the ratio of the Taxes (in $) of Congo (Democratic) in 2006 to that in 2008?
Provide a succinct answer. 0.47. What is the ratio of the Taxes (in $) in Dominican Republic in 2006 to that in 2008?
Your answer should be compact. 0.74. What is the ratio of the Taxes (in $) in Ethiopia in 2006 to that in 2008?
Keep it short and to the point. 0.5. What is the ratio of the Taxes (in $) of New Zealand in 2006 to that in 2008?
Make the answer very short. 1.02. What is the ratio of the Taxes (in $) in Congo (Democratic) in 2006 to that in 2009?
Ensure brevity in your answer.  0.36. What is the ratio of the Taxes (in $) in Dominican Republic in 2006 to that in 2009?
Provide a short and direct response. 0.78. What is the ratio of the Taxes (in $) of Ethiopia in 2006 to that in 2009?
Offer a terse response. 0.45. What is the ratio of the Taxes (in $) in New Zealand in 2006 to that in 2009?
Give a very brief answer. 0.87. What is the ratio of the Taxes (in $) of Congo (Democratic) in 2006 to that in 2010?
Keep it short and to the point. 0.26. What is the ratio of the Taxes (in $) in Dominican Republic in 2006 to that in 2010?
Give a very brief answer. 0.68. What is the ratio of the Taxes (in $) of Ethiopia in 2006 to that in 2010?
Offer a terse response. 0.42. What is the ratio of the Taxes (in $) of New Zealand in 2006 to that in 2010?
Offer a terse response. 0.84. What is the ratio of the Taxes (in $) of Congo (Democratic) in 2007 to that in 2008?
Keep it short and to the point. 0.62. What is the ratio of the Taxes (in $) in Dominican Republic in 2007 to that in 2008?
Ensure brevity in your answer.  0.92. What is the ratio of the Taxes (in $) in Ethiopia in 2007 to that in 2008?
Your response must be concise. 0.57. What is the ratio of the Taxes (in $) of New Zealand in 2007 to that in 2008?
Your answer should be compact. 1.03. What is the ratio of the Taxes (in $) of Congo (Democratic) in 2007 to that in 2009?
Your response must be concise. 0.47. What is the ratio of the Taxes (in $) of Dominican Republic in 2007 to that in 2009?
Your answer should be very brief. 0.97. What is the ratio of the Taxes (in $) in Ethiopia in 2007 to that in 2009?
Provide a short and direct response. 0.51. What is the ratio of the Taxes (in $) of New Zealand in 2007 to that in 2009?
Offer a terse response. 0.89. What is the ratio of the Taxes (in $) in Congo (Democratic) in 2007 to that in 2010?
Make the answer very short. 0.34. What is the ratio of the Taxes (in $) of Dominican Republic in 2007 to that in 2010?
Provide a succinct answer. 0.84. What is the ratio of the Taxes (in $) in Ethiopia in 2007 to that in 2010?
Your response must be concise. 0.48. What is the ratio of the Taxes (in $) in New Zealand in 2007 to that in 2010?
Provide a short and direct response. 0.85. What is the ratio of the Taxes (in $) in Congo (Democratic) in 2008 to that in 2009?
Make the answer very short. 0.77. What is the ratio of the Taxes (in $) of Dominican Republic in 2008 to that in 2009?
Make the answer very short. 1.06. What is the ratio of the Taxes (in $) in Ethiopia in 2008 to that in 2009?
Your answer should be compact. 0.89. What is the ratio of the Taxes (in $) in New Zealand in 2008 to that in 2009?
Give a very brief answer. 0.86. What is the ratio of the Taxes (in $) of Congo (Democratic) in 2008 to that in 2010?
Your answer should be very brief. 0.56. What is the ratio of the Taxes (in $) of Dominican Republic in 2008 to that in 2010?
Keep it short and to the point. 0.92. What is the ratio of the Taxes (in $) of Ethiopia in 2008 to that in 2010?
Your answer should be very brief. 0.83. What is the ratio of the Taxes (in $) in New Zealand in 2008 to that in 2010?
Provide a succinct answer. 0.82. What is the ratio of the Taxes (in $) in Congo (Democratic) in 2009 to that in 2010?
Your response must be concise. 0.73. What is the ratio of the Taxes (in $) of Dominican Republic in 2009 to that in 2010?
Offer a terse response. 0.87. What is the ratio of the Taxes (in $) in Ethiopia in 2009 to that in 2010?
Ensure brevity in your answer.  0.93. What is the ratio of the Taxes (in $) in New Zealand in 2009 to that in 2010?
Offer a very short reply. 0.96. What is the difference between the highest and the second highest Taxes (in $) of Congo (Democratic)?
Your answer should be compact. 1.52e+11. What is the difference between the highest and the second highest Taxes (in $) in Dominican Republic?
Provide a short and direct response. 1.20e+1. What is the difference between the highest and the second highest Taxes (in $) of Ethiopia?
Offer a very short reply. 3.83e+08. What is the difference between the highest and the second highest Taxes (in $) in New Zealand?
Provide a succinct answer. 8.25e+08. What is the difference between the highest and the lowest Taxes (in $) in Congo (Democratic)?
Offer a very short reply. 4.52e+11. What is the difference between the highest and the lowest Taxes (in $) of Dominican Republic?
Offer a very short reply. 7.47e+1. What is the difference between the highest and the lowest Taxes (in $) in Ethiopia?
Ensure brevity in your answer.  3.77e+09. What is the difference between the highest and the lowest Taxes (in $) of New Zealand?
Your answer should be very brief. 4.00e+09. 